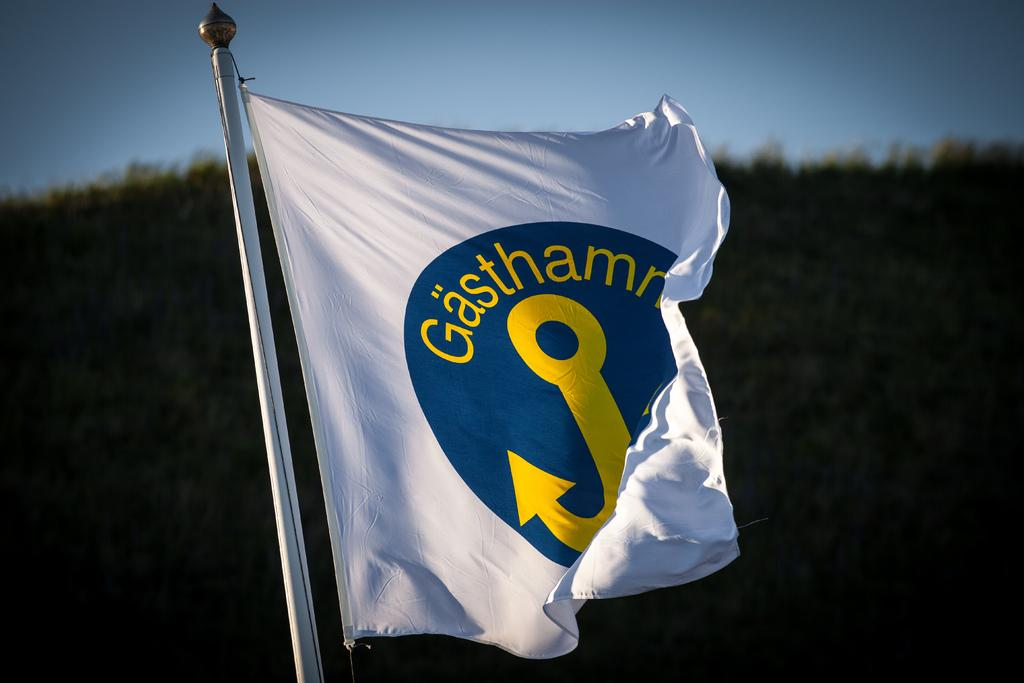What is the main object in the image? There is a flag with a pole in the image. Can you describe the background of the image? The background of the image is blurred. What type of grain is visible in the image? There is no grain visible in the image; it only features a flag with a pole and a blurred background. 